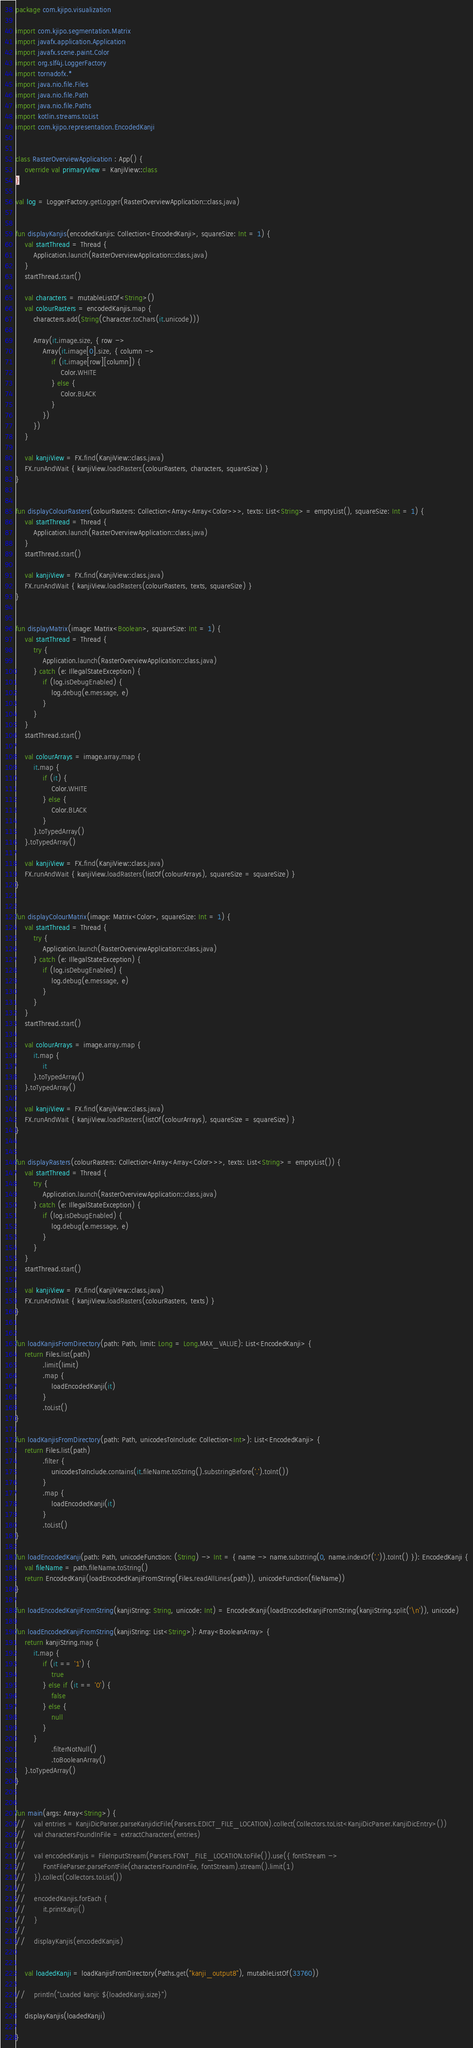<code> <loc_0><loc_0><loc_500><loc_500><_Kotlin_>package com.kjipo.visualization

import com.kjipo.segmentation.Matrix
import javafx.application.Application
import javafx.scene.paint.Color
import org.slf4j.LoggerFactory
import tornadofx.*
import java.nio.file.Files
import java.nio.file.Path
import java.nio.file.Paths
import kotlin.streams.toList
import com.kjipo.representation.EncodedKanji


class RasterOverviewApplication : App() {
    override val primaryView = KanjiView::class
}

val log = LoggerFactory.getLogger(RasterOverviewApplication::class.java)


fun displayKanjis(encodedKanjis: Collection<EncodedKanji>, squareSize: Int = 1) {
    val startThread = Thread {
        Application.launch(RasterOverviewApplication::class.java)
    }
    startThread.start()

    val characters = mutableListOf<String>()
    val colourRasters = encodedKanjis.map {
        characters.add(String(Character.toChars(it.unicode)))

        Array(it.image.size, { row ->
            Array(it.image[0].size, { column ->
                if (it.image[row][column]) {
                    Color.WHITE
                } else {
                    Color.BLACK
                }
            })
        })
    }

    val kanjiView = FX.find(KanjiView::class.java)
    FX.runAndWait { kanjiView.loadRasters(colourRasters, characters, squareSize) }
}


fun displayColourRasters(colourRasters: Collection<Array<Array<Color>>>, texts: List<String> = emptyList(), squareSize: Int = 1) {
    val startThread = Thread {
        Application.launch(RasterOverviewApplication::class.java)
    }
    startThread.start()

    val kanjiView = FX.find(KanjiView::class.java)
    FX.runAndWait { kanjiView.loadRasters(colourRasters, texts, squareSize) }
}


fun displayMatrix(image: Matrix<Boolean>, squareSize: Int = 1) {
    val startThread = Thread {
        try {
            Application.launch(RasterOverviewApplication::class.java)
        } catch (e: IllegalStateException) {
            if (log.isDebugEnabled) {
                log.debug(e.message, e)
            }
        }
    }
    startThread.start()

    val colourArrays = image.array.map {
        it.map {
            if (it) {
                Color.WHITE
            } else {
                Color.BLACK
            }
        }.toTypedArray()
    }.toTypedArray()

    val kanjiView = FX.find(KanjiView::class.java)
    FX.runAndWait { kanjiView.loadRasters(listOf(colourArrays), squareSize = squareSize) }
}


fun displayColourMatrix(image: Matrix<Color>, squareSize: Int = 1) {
    val startThread = Thread {
        try {
            Application.launch(RasterOverviewApplication::class.java)
        } catch (e: IllegalStateException) {
            if (log.isDebugEnabled) {
                log.debug(e.message, e)
            }
        }
    }
    startThread.start()

    val colourArrays = image.array.map {
        it.map {
            it
        }.toTypedArray()
    }.toTypedArray()

    val kanjiView = FX.find(KanjiView::class.java)
    FX.runAndWait { kanjiView.loadRasters(listOf(colourArrays), squareSize = squareSize) }
}


fun displayRasters(colourRasters: Collection<Array<Array<Color>>>, texts: List<String> = emptyList()) {
    val startThread = Thread {
        try {
            Application.launch(RasterOverviewApplication::class.java)
        } catch (e: IllegalStateException) {
            if (log.isDebugEnabled) {
                log.debug(e.message, e)
            }
        }
    }
    startThread.start()

    val kanjiView = FX.find(KanjiView::class.java)
    FX.runAndWait { kanjiView.loadRasters(colourRasters, texts) }
}


fun loadKanjisFromDirectory(path: Path, limit: Long = Long.MAX_VALUE): List<EncodedKanji> {
    return Files.list(path)
            .limit(limit)
            .map {
                loadEncodedKanji(it)
            }
            .toList()
}

fun loadKanjisFromDirectory(path: Path, unicodesToInclude: Collection<Int>): List<EncodedKanji> {
    return Files.list(path)
            .filter {
                unicodesToInclude.contains(it.fileName.toString().substringBefore('.').toInt())
            }
            .map {
                loadEncodedKanji(it)
            }
            .toList()
}

fun loadEncodedKanji(path: Path, unicodeFunction: (String) -> Int = { name -> name.substring(0, name.indexOf('.')).toInt() }): EncodedKanji {
    val fileName = path.fileName.toString()
    return EncodedKanji(loadEncodedKanjiFromString(Files.readAllLines(path)), unicodeFunction(fileName))
}

fun loadEncodedKanjiFromString(kanjiString: String, unicode: Int) = EncodedKanji(loadEncodedKanjiFromString(kanjiString.split('\n')), unicode)

fun loadEncodedKanjiFromString(kanjiString: List<String>): Array<BooleanArray> {
    return kanjiString.map {
        it.map {
            if (it == '1') {
                true
            } else if (it == '0') {
                false
            } else {
                null
            }
        }
                .filterNotNull()
                .toBooleanArray()
    }.toTypedArray()
}


fun main(args: Array<String>) {
//    val entries = KanjiDicParser.parseKanjidicFile(Parsers.EDICT_FILE_LOCATION).collect(Collectors.toList<KanjiDicParser.KanjiDicEntry>())
//    val charactersFoundInFile = extractCharacters(entries)
//
//    val encodedKanjis = FileInputStream(Parsers.FONT_FILE_LOCATION.toFile()).use({ fontStream ->
//        FontFileParser.parseFontFile(charactersFoundInFile, fontStream).stream().limit(1)
//    }).collect(Collectors.toList())
//
//    encodedKanjis.forEach {
//        it.printKanji()
//    }
//
//    displayKanjis(encodedKanjis)


    val loadedKanji = loadKanjisFromDirectory(Paths.get("kanji_output8"), mutableListOf(33760))

//    println("Loaded kanji: ${loadedKanji.size}")

    displayKanjis(loadedKanji)

}</code> 